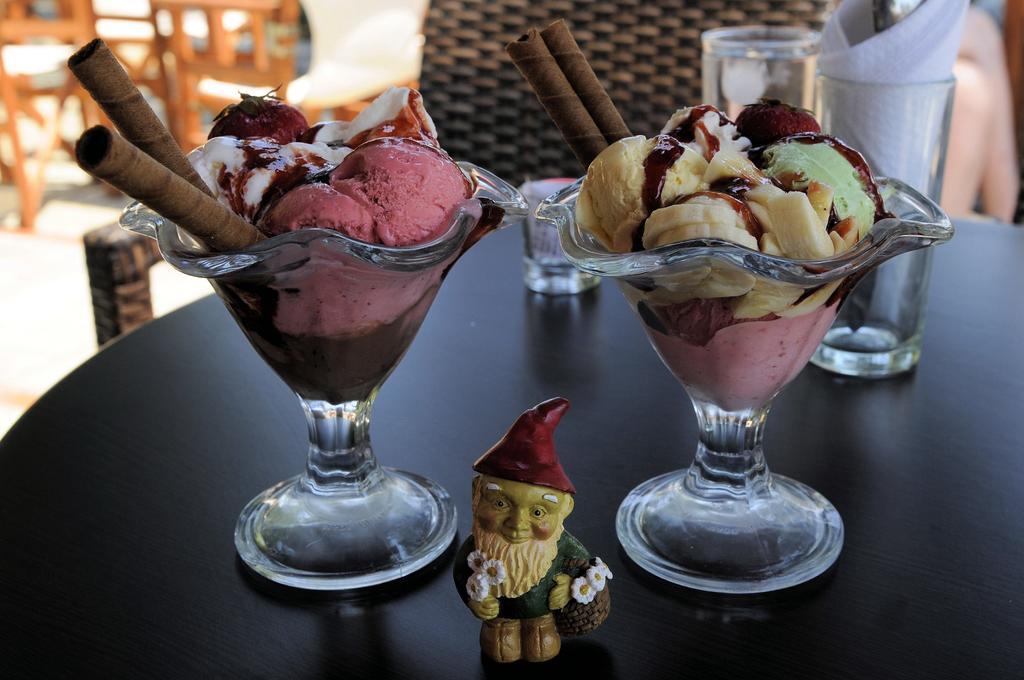Please provide a concise description of this image. In this image in front there is a table and on top of the table there are glasses, tissues and ice creams. Behind the table there are chairs. 